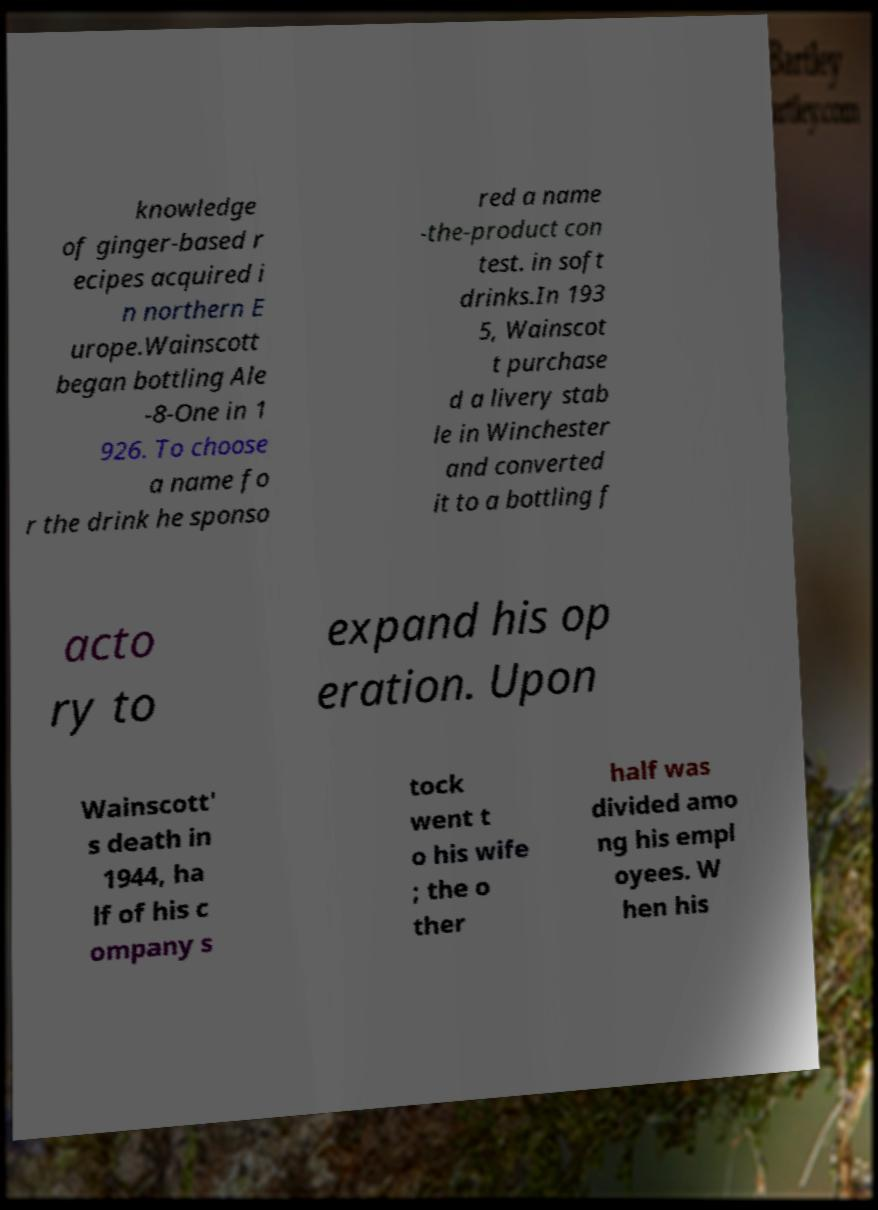What messages or text are displayed in this image? I need them in a readable, typed format. knowledge of ginger-based r ecipes acquired i n northern E urope.Wainscott began bottling Ale -8-One in 1 926. To choose a name fo r the drink he sponso red a name -the-product con test. in soft drinks.In 193 5, Wainscot t purchase d a livery stab le in Winchester and converted it to a bottling f acto ry to expand his op eration. Upon Wainscott' s death in 1944, ha lf of his c ompany s tock went t o his wife ; the o ther half was divided amo ng his empl oyees. W hen his 